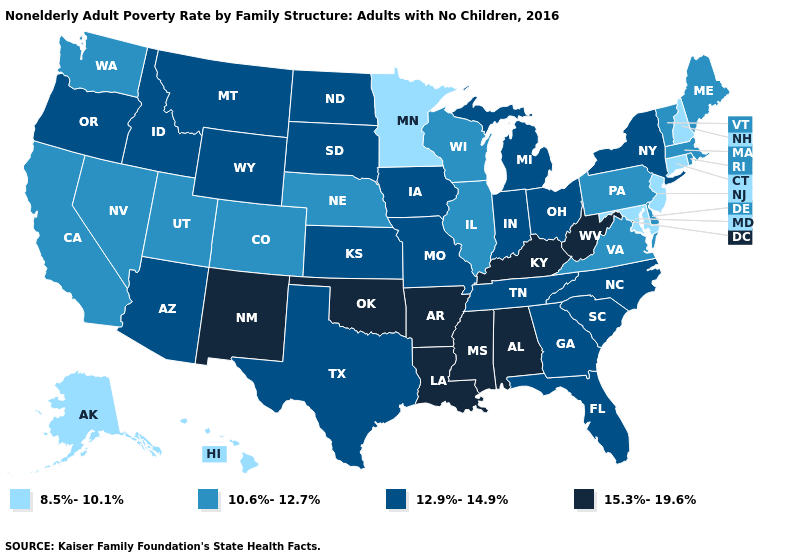How many symbols are there in the legend?
Short answer required. 4. What is the highest value in the West ?
Answer briefly. 15.3%-19.6%. Does New York have a lower value than Alabama?
Keep it brief. Yes. What is the highest value in states that border Tennessee?
Keep it brief. 15.3%-19.6%. Name the states that have a value in the range 8.5%-10.1%?
Answer briefly. Alaska, Connecticut, Hawaii, Maryland, Minnesota, New Hampshire, New Jersey. Name the states that have a value in the range 10.6%-12.7%?
Give a very brief answer. California, Colorado, Delaware, Illinois, Maine, Massachusetts, Nebraska, Nevada, Pennsylvania, Rhode Island, Utah, Vermont, Virginia, Washington, Wisconsin. Among the states that border North Carolina , does Virginia have the lowest value?
Answer briefly. Yes. Does Louisiana have the lowest value in the South?
Quick response, please. No. Does Washington have a lower value than Kentucky?
Give a very brief answer. Yes. What is the value of Hawaii?
Be succinct. 8.5%-10.1%. What is the value of South Carolina?
Quick response, please. 12.9%-14.9%. Name the states that have a value in the range 12.9%-14.9%?
Write a very short answer. Arizona, Florida, Georgia, Idaho, Indiana, Iowa, Kansas, Michigan, Missouri, Montana, New York, North Carolina, North Dakota, Ohio, Oregon, South Carolina, South Dakota, Tennessee, Texas, Wyoming. What is the highest value in the USA?
Answer briefly. 15.3%-19.6%. Which states have the highest value in the USA?
Quick response, please. Alabama, Arkansas, Kentucky, Louisiana, Mississippi, New Mexico, Oklahoma, West Virginia. What is the lowest value in the Northeast?
Keep it brief. 8.5%-10.1%. 